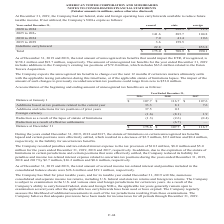According to American Tower Corporation's financial document, What was the company's Federal NOLs expiring in 2025 to 2029? According to the financial document, 141.6 (in millions). The relevant text states: "2025 to 2029 141.6 285.7 104.8..." Also, What was the company's State NOLs expiring in 2020 to 2024? According to the financial document, $222.3 (in millions). The relevant text states: "2020 to 2024 $ — $ 222.3 $ 11.9..." Also, What was the company's Foreign NOLs expiring in 2030 to 2034? According to the financial document, 19.6 (in millions). The relevant text states: "2030 to 2034 7.0 41.4 19.6..." Also, can you calculate: What is the difference between Federal and State NOLs in the period 2025 to 2029? Based on the calculation: 285.7-141.6, the result is 144.1 (in millions). This is based on the information: "2025 to 2029 141.6 285.7 104.8 2025 to 2029 141.6 285.7 104.8..." The key data points involved are: 141.6, 285.7. Also, can you calculate: What was the Federal NOL as a ratio of Foreign NOL in the period 2030 to 2034? Based on the calculation: 7.0/19.6, the result is 35.71 (percentage). This is based on the information: "2030 to 2034 7.0 41.4 19.6 2030 to 2034 7.0 41.4 19.6..." The key data points involved are: 19.6, 7.0. Also, can you calculate: What is the sum of the company's total NOLs? Based on the calculation: $175.0+$708.9+$990.1, the result is 1874 (in millions). This is based on the information: "efinite carryforward 22.8 — 853.8 Total $ 175.0 $ 708.9 $ 990.1 carryforward 22.8 — 853.8 Total $ 175.0 $ 708.9 $ 990.1 Indefinite carryforward 22.8 — 853.8 Total $ 175.0 $ 708.9 $ 990.1..." The key data points involved are: 175.0, 708.9, 990.1. 